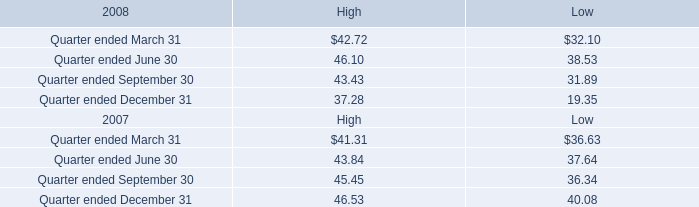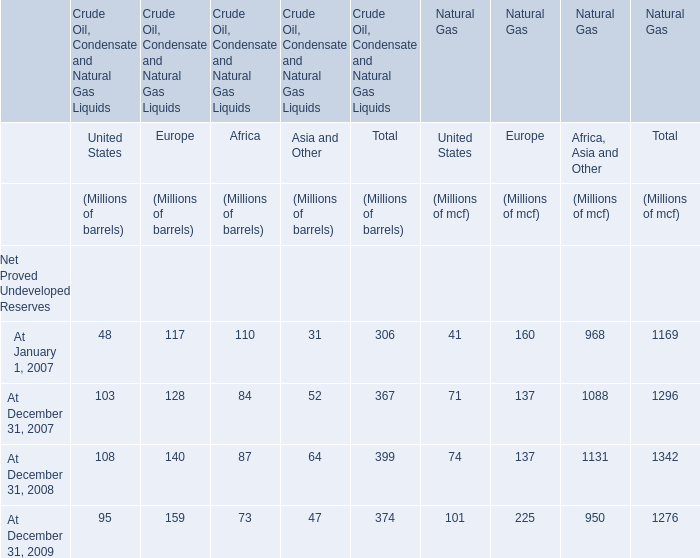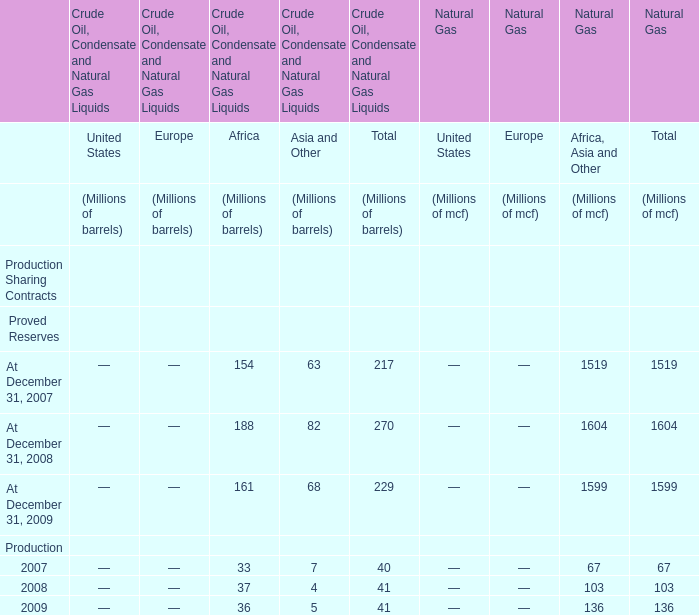what is the average number of common stock shares per register holder as of february 13 , 2009? 
Computations: (397097677 / 499)
Answer: 795786.92786. 